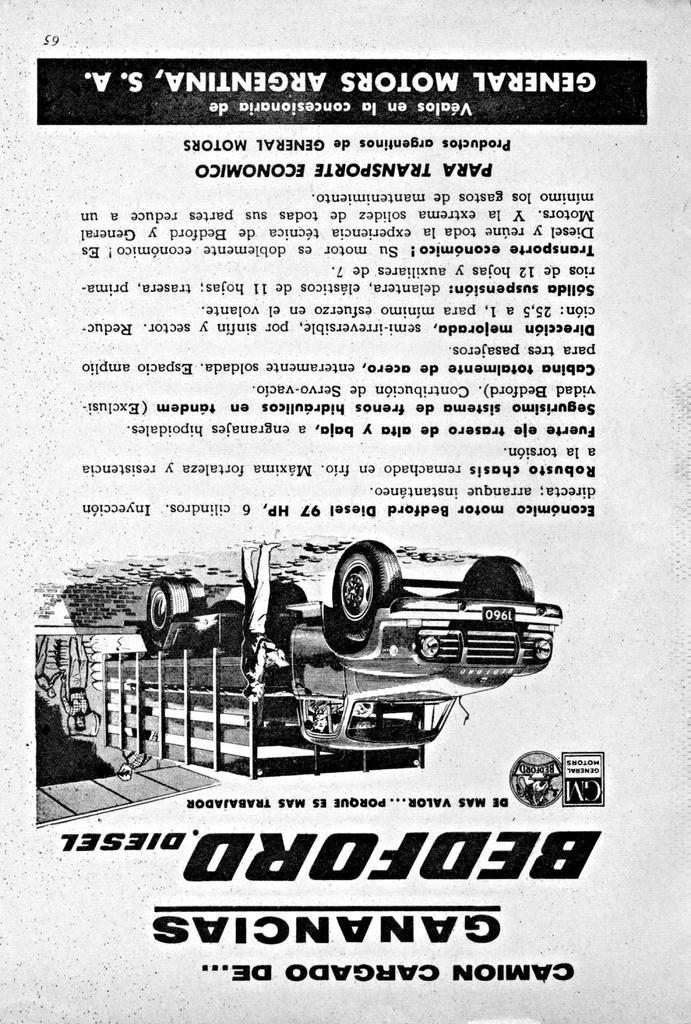Please provide a concise description of this image. This is a poster having animated image and black and white color texts. In this image, we can see there is a vehicle and there are persons. And the background of this poster is white in color. 